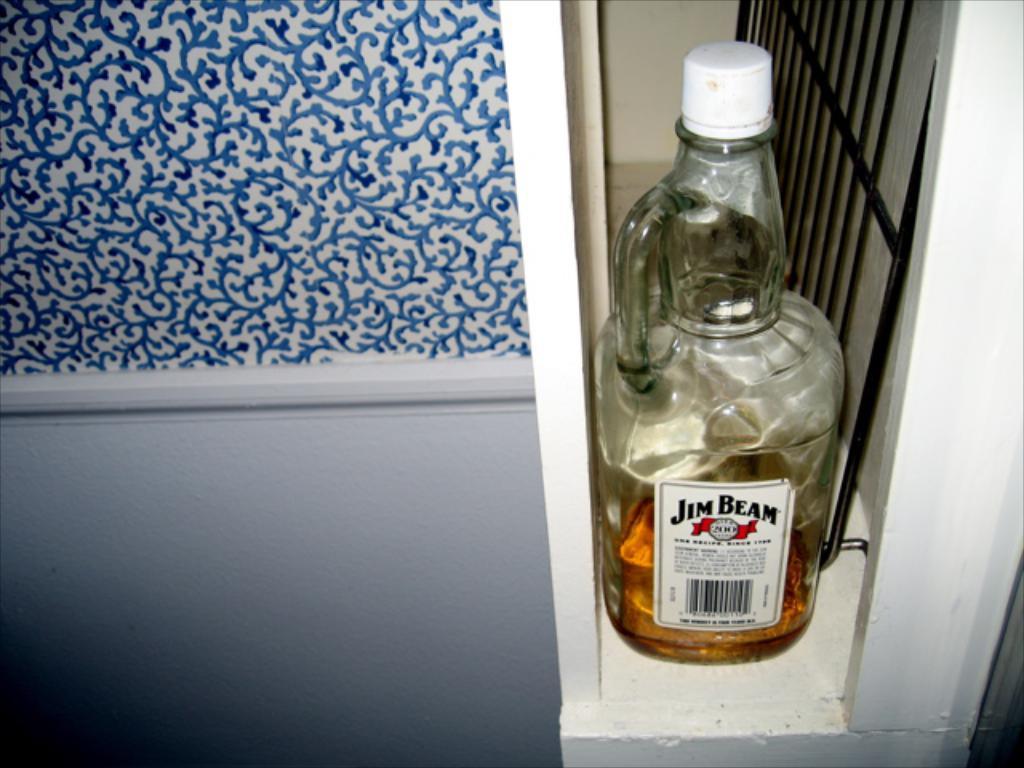What is the brand?
Your answer should be compact. Jim beam. 